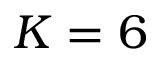Convert formula to latex. <formula><loc_0><loc_0><loc_500><loc_500>K = 6</formula> 